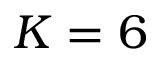Convert formula to latex. <formula><loc_0><loc_0><loc_500><loc_500>K = 6</formula> 